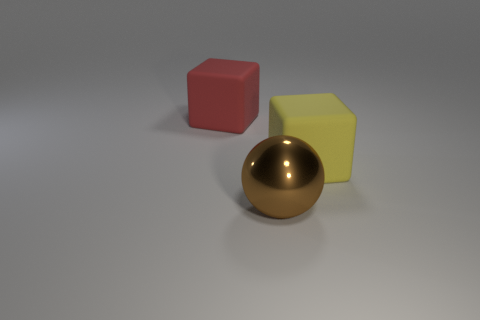What number of objects are matte objects on the left side of the ball or things to the right of the red rubber cube?
Offer a very short reply. 3. There is a red thing that is the same size as the yellow matte block; what shape is it?
Offer a terse response. Cube. The red cube that is the same material as the big yellow block is what size?
Your answer should be compact. Large. Is the shape of the large red matte thing the same as the big brown object?
Offer a very short reply. No. What is the color of the other matte thing that is the same size as the yellow rubber thing?
Give a very brief answer. Red. There is a red thing that is the same shape as the large yellow object; what is its size?
Give a very brief answer. Large. There is a rubber thing in front of the big red matte thing; what is its shape?
Provide a short and direct response. Cube. There is a red rubber thing; does it have the same shape as the yellow matte thing to the right of the big ball?
Ensure brevity in your answer.  Yes. Are there an equal number of large yellow rubber things that are behind the big yellow rubber cube and red things that are in front of the sphere?
Offer a very short reply. Yes. Is the number of large yellow matte blocks that are behind the metallic object greater than the number of tiny yellow cylinders?
Offer a very short reply. Yes. 